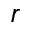Convert formula to latex. <formula><loc_0><loc_0><loc_500><loc_500>r</formula> 